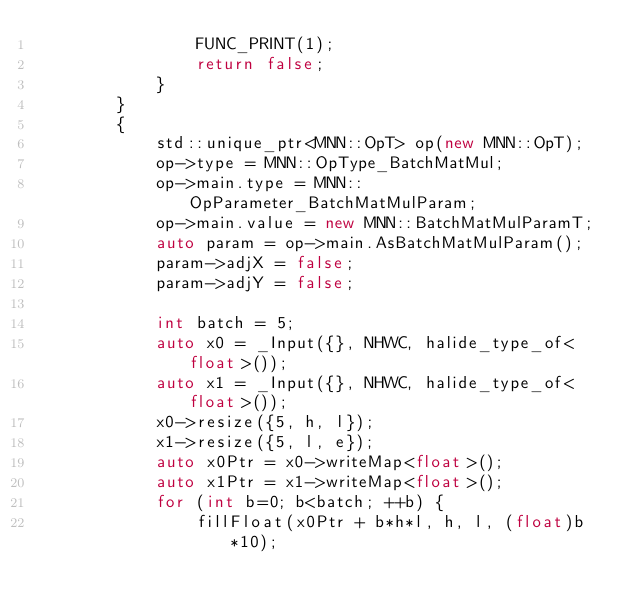<code> <loc_0><loc_0><loc_500><loc_500><_C++_>                FUNC_PRINT(1);
                return false;
            }
        }
        {
            std::unique_ptr<MNN::OpT> op(new MNN::OpT);
            op->type = MNN::OpType_BatchMatMul;
            op->main.type = MNN::OpParameter_BatchMatMulParam;
            op->main.value = new MNN::BatchMatMulParamT;
            auto param = op->main.AsBatchMatMulParam();
            param->adjX = false;
            param->adjY = false;

            int batch = 5;
            auto x0 = _Input({}, NHWC, halide_type_of<float>());
            auto x1 = _Input({}, NHWC, halide_type_of<float>());
            x0->resize({5, h, l});
            x1->resize({5, l, e});
            auto x0Ptr = x0->writeMap<float>();
            auto x1Ptr = x1->writeMap<float>();
            for (int b=0; b<batch; ++b) {
                fillFloat(x0Ptr + b*h*l, h, l, (float)b*10);</code> 